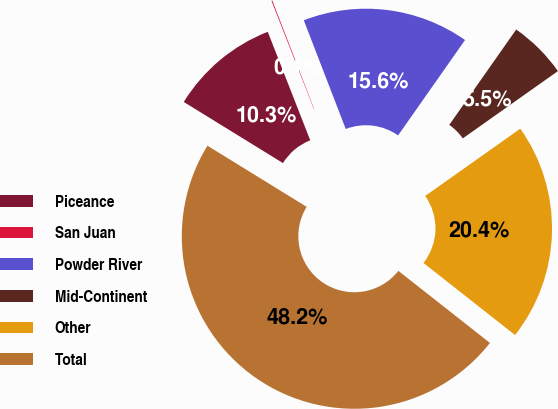<chart> <loc_0><loc_0><loc_500><loc_500><pie_chart><fcel>Piceance<fcel>San Juan<fcel>Powder River<fcel>Mid-Continent<fcel>Other<fcel>Total<nl><fcel>10.27%<fcel>0.08%<fcel>15.6%<fcel>5.46%<fcel>20.41%<fcel>48.18%<nl></chart> 